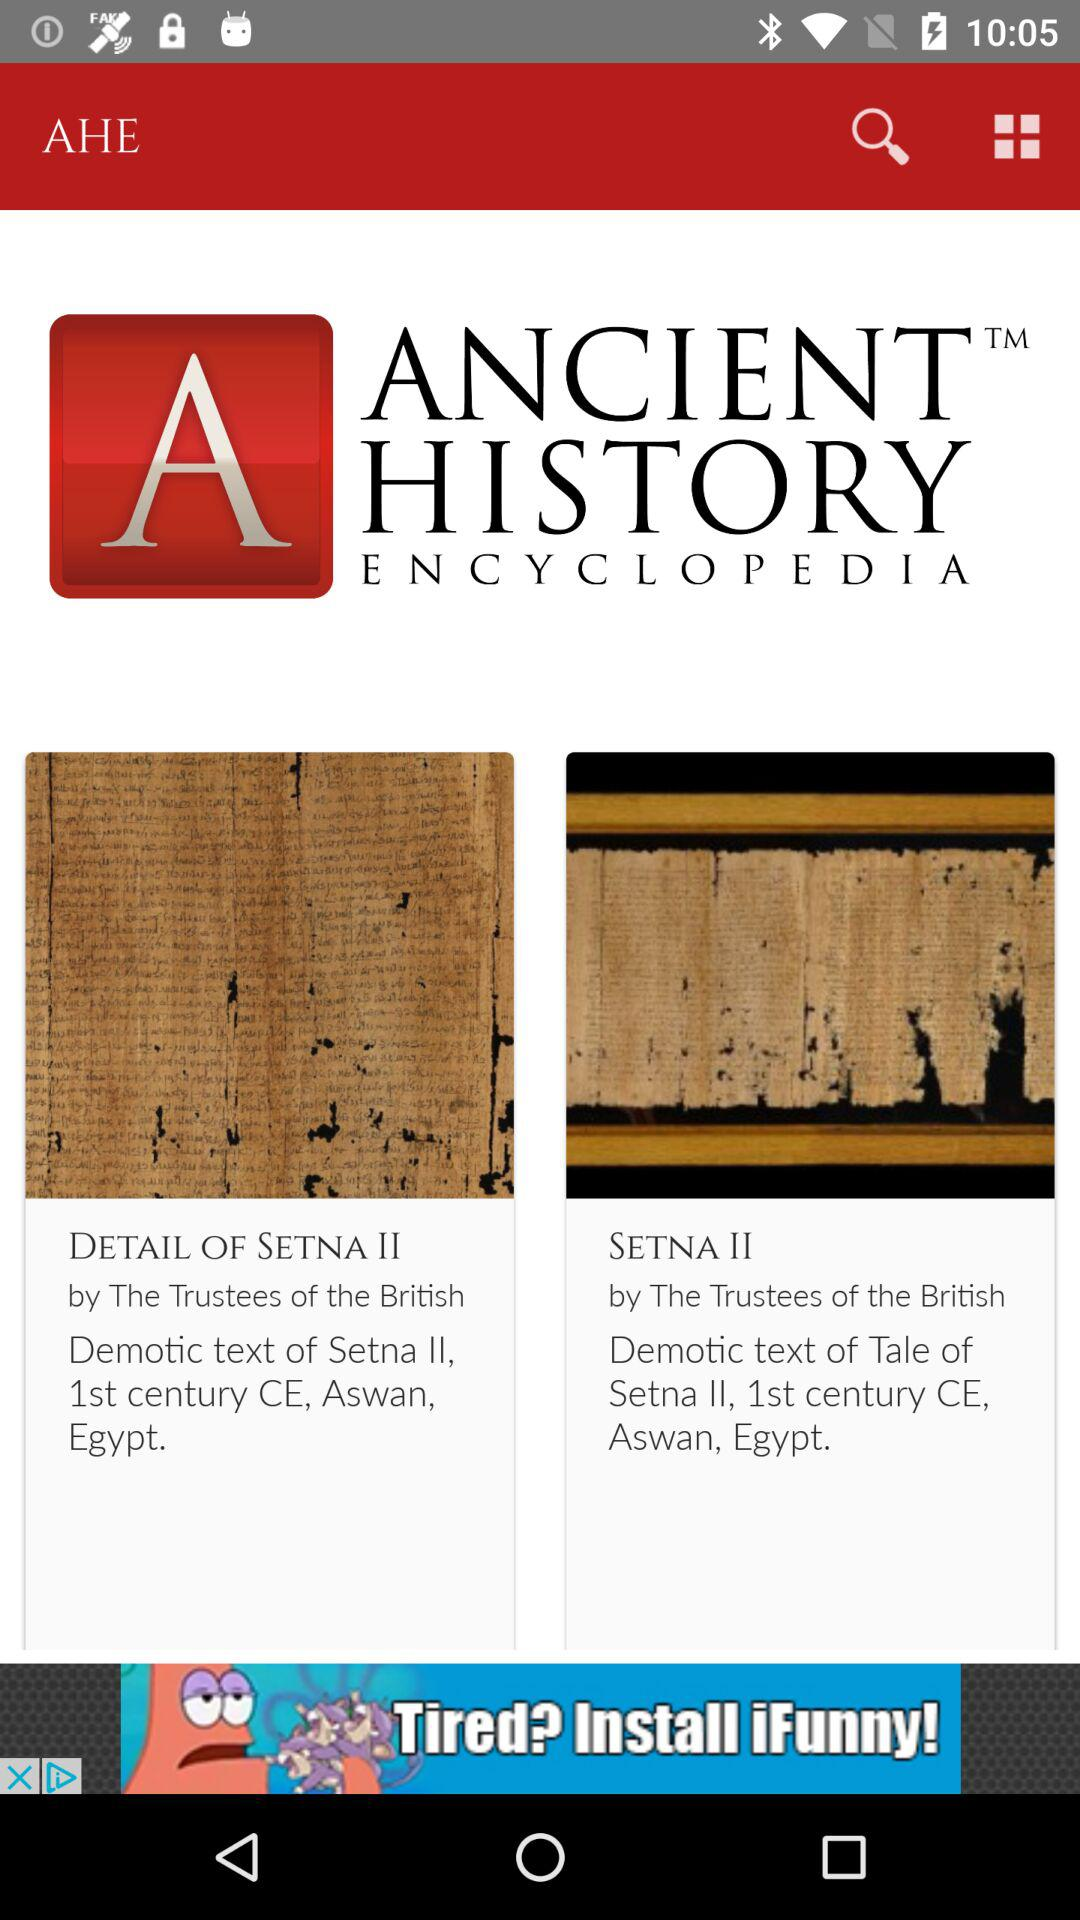What is the app name? The app name is "Ancient History Encyclopedia". 